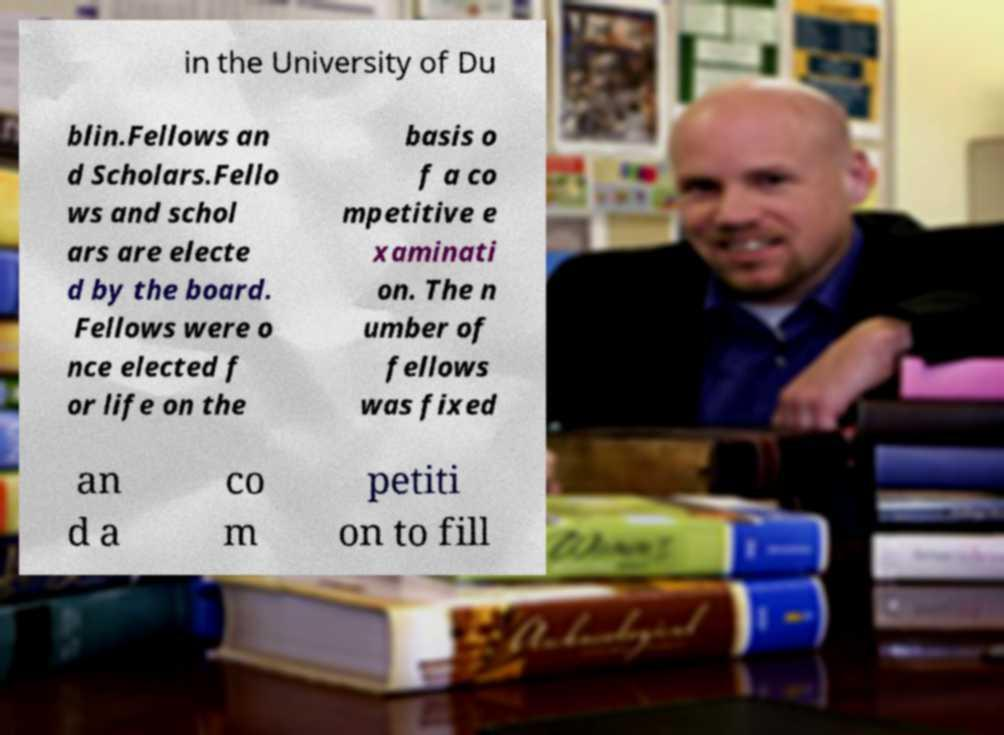Could you extract and type out the text from this image? in the University of Du blin.Fellows an d Scholars.Fello ws and schol ars are electe d by the board. Fellows were o nce elected f or life on the basis o f a co mpetitive e xaminati on. The n umber of fellows was fixed an d a co m petiti on to fill 